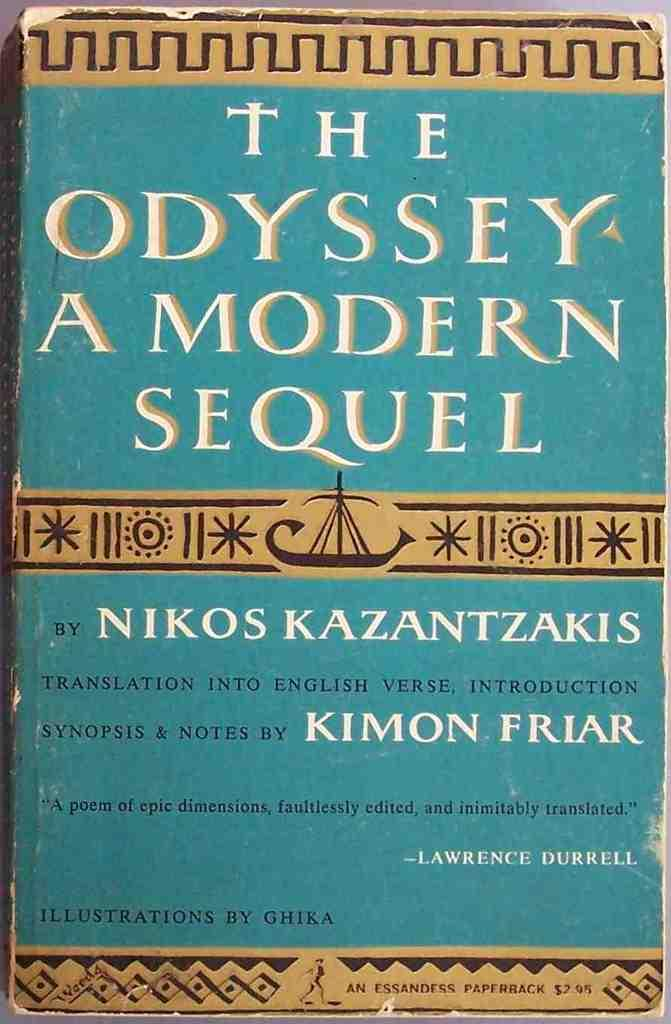What is present on the poster in the image? The poster contains symbols, a quotation, and other texts. Can you describe the symbols on the poster? Unfortunately, the specific symbols on the poster cannot be described without more information. What type of text is present on the poster besides the quotation? The poster contains other texts, but their content cannot be determined without more information. What color is the skirt on the poster? There is no skirt present on the poster; it contains symbols, a quotation, and other texts. 